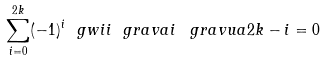Convert formula to latex. <formula><loc_0><loc_0><loc_500><loc_500>\sum _ { i = 0 } ^ { 2 k } ( - 1 ) ^ { i } \ g w i i { \ g r a v a { i } \, \ g r a v u a { 2 k - i } } = 0</formula> 